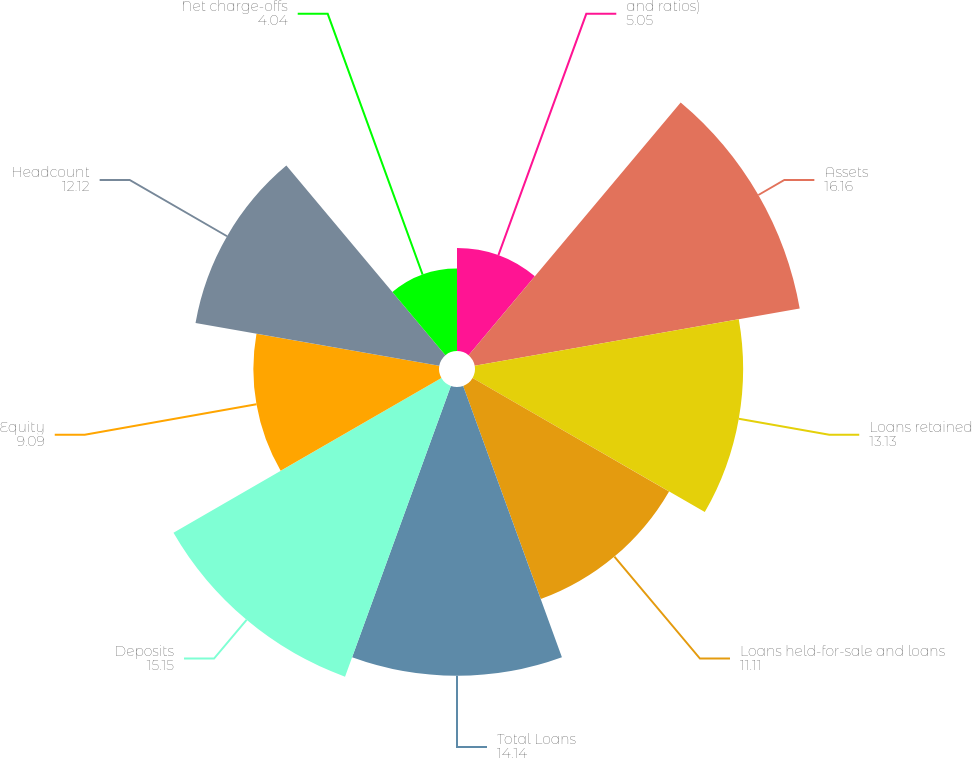Convert chart to OTSL. <chart><loc_0><loc_0><loc_500><loc_500><pie_chart><fcel>and ratios)<fcel>Assets<fcel>Loans retained<fcel>Loans held-for-sale and loans<fcel>Total Loans<fcel>Deposits<fcel>Equity<fcel>Headcount<fcel>Net charge-offs<nl><fcel>5.05%<fcel>16.16%<fcel>13.13%<fcel>11.11%<fcel>14.14%<fcel>15.15%<fcel>9.09%<fcel>12.12%<fcel>4.04%<nl></chart> 